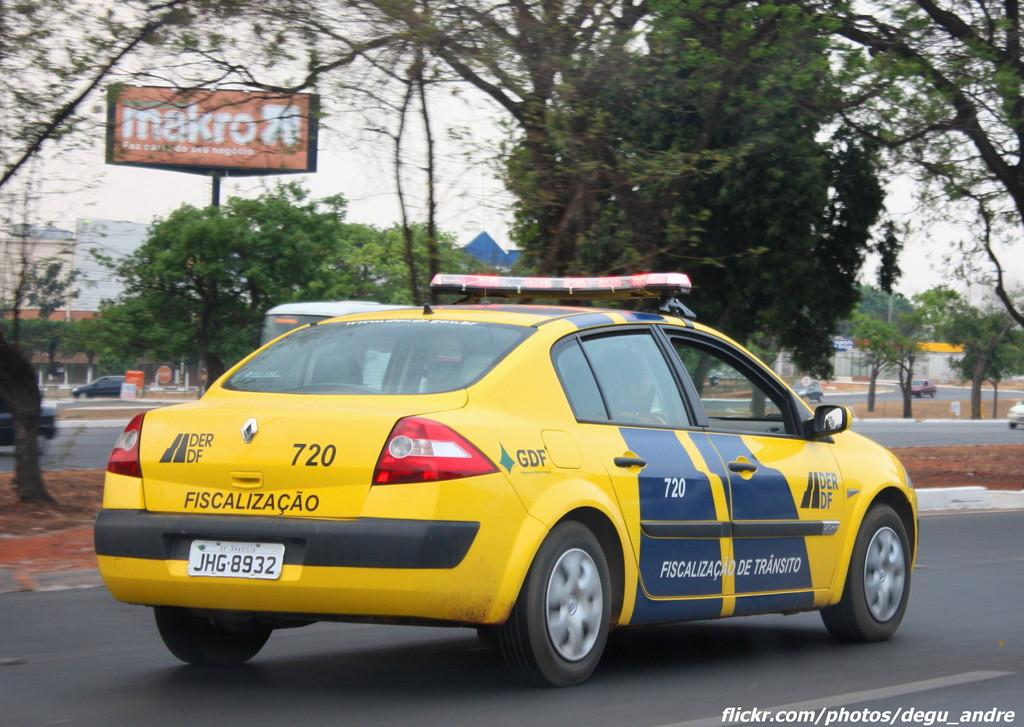<image>
Describe the image concisely. A yellow vehicle with the word Fiscalizacao printed on the back, is driving down the road. 